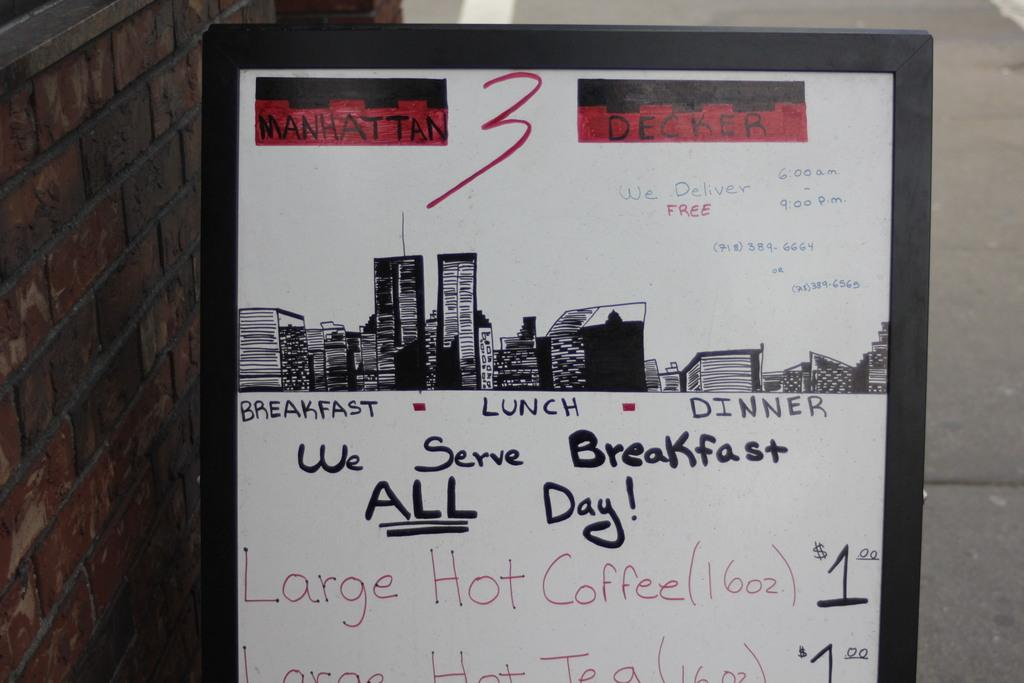Provide a one-sentence caption for the provided image. Sign that lets customers know that the restaurant serves breakfast all day. 